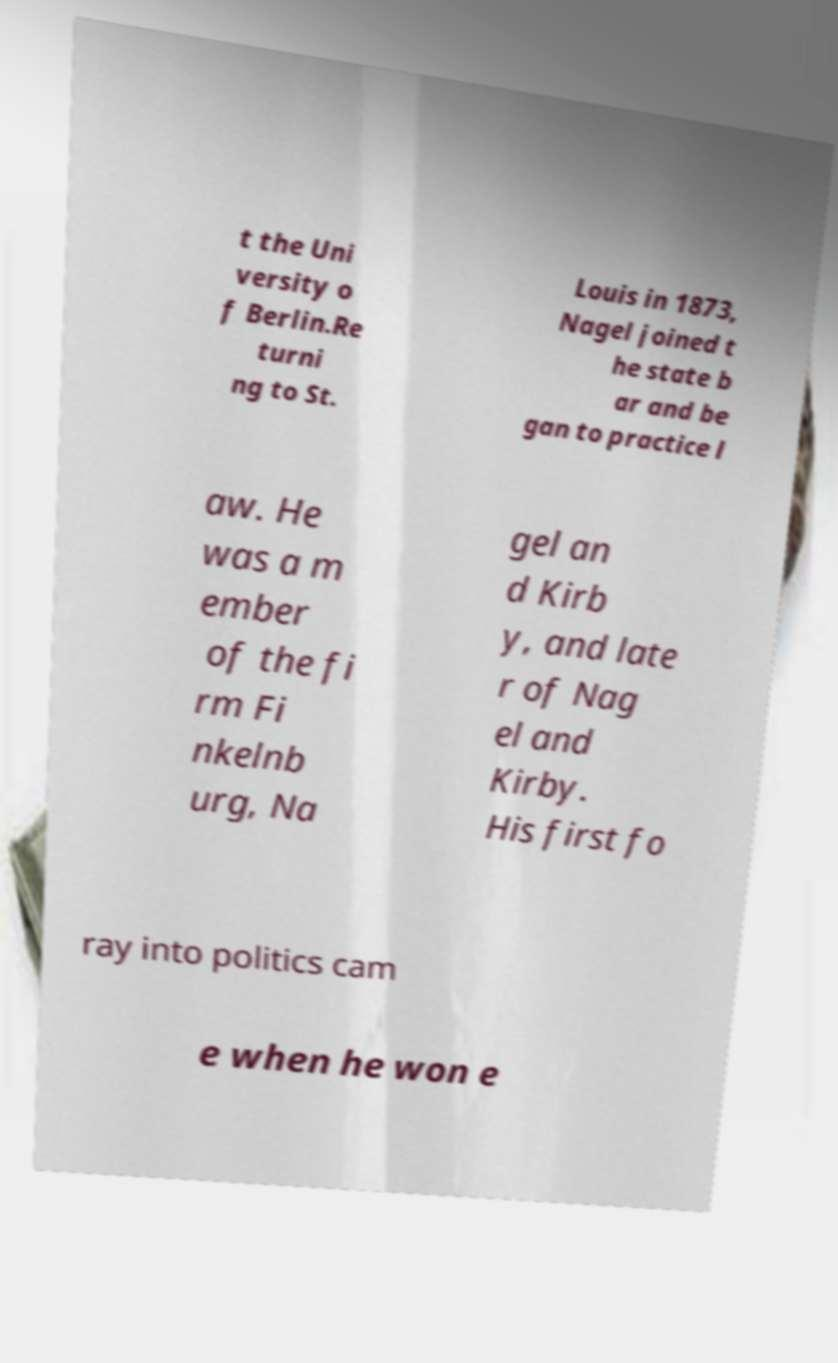Please read and relay the text visible in this image. What does it say? t the Uni versity o f Berlin.Re turni ng to St. Louis in 1873, Nagel joined t he state b ar and be gan to practice l aw. He was a m ember of the fi rm Fi nkelnb urg, Na gel an d Kirb y, and late r of Nag el and Kirby. His first fo ray into politics cam e when he won e 